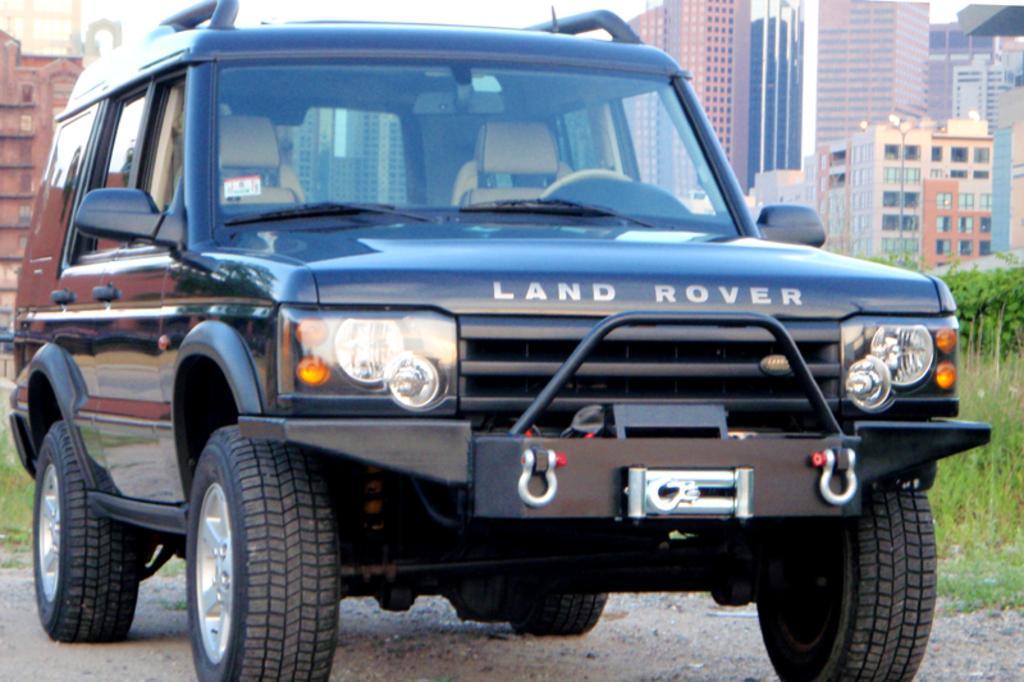Please provide a concise description of this image. In this picture there is a vehicle on the road and there is a text on the vehicle. At the back there are buildings and trees. At the top there is sky. At the bottom there is a road and there is grass. 